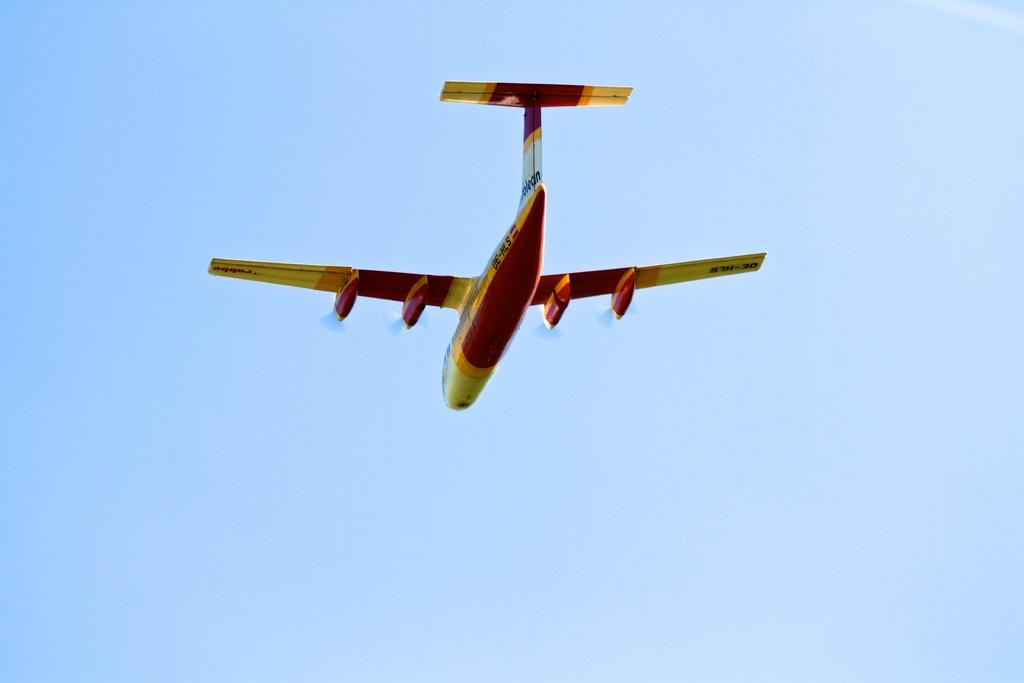What is the main subject of the image? The main subject of the image is a plane. What is the plane doing in the image? The plane is flying in the sky. What colors are used to paint the plane? The plane is in red and yellow color. How many grains of sand can be seen on the plane in the image? There is no sand present on the plane in the image. What type of eyes can be seen on the plane in the image? There are no eyes present on the plane in the image. 